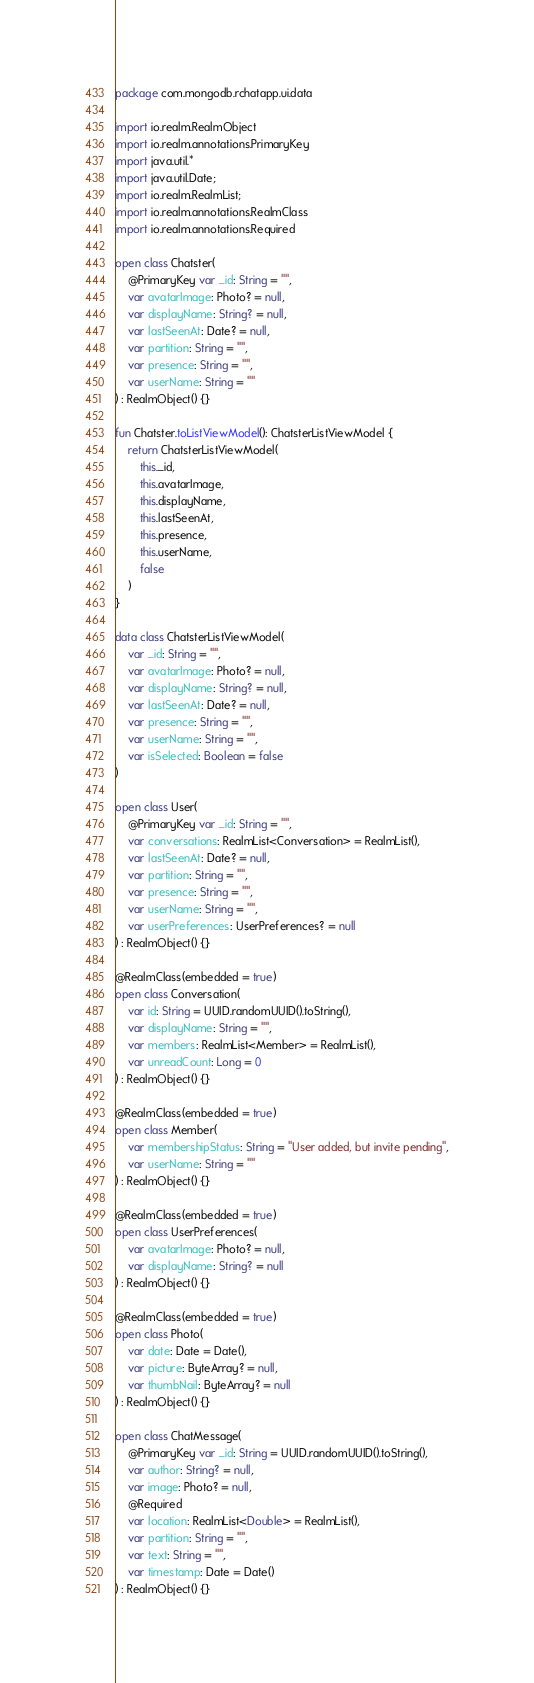Convert code to text. <code><loc_0><loc_0><loc_500><loc_500><_Kotlin_>package com.mongodb.rchatapp.ui.data

import io.realm.RealmObject
import io.realm.annotations.PrimaryKey
import java.util.*
import java.util.Date;
import io.realm.RealmList;
import io.realm.annotations.RealmClass
import io.realm.annotations.Required

open class Chatster(
    @PrimaryKey var _id: String = "",
    var avatarImage: Photo? = null,
    var displayName: String? = null,
    var lastSeenAt: Date? = null,
    var partition: String = "",
    var presence: String = "",
    var userName: String = ""
) : RealmObject() {}

fun Chatster.toListViewModel(): ChatsterListViewModel {
    return ChatsterListViewModel(
        this._id,
        this.avatarImage,
        this.displayName,
        this.lastSeenAt,
        this.presence,
        this.userName,
        false
    )
}

data class ChatsterListViewModel(
    var _id: String = "",
    var avatarImage: Photo? = null,
    var displayName: String? = null,
    var lastSeenAt: Date? = null,
    var presence: String = "",
    var userName: String = "",
    var isSelected: Boolean = false
)

open class User(
    @PrimaryKey var _id: String = "",
    var conversations: RealmList<Conversation> = RealmList(),
    var lastSeenAt: Date? = null,
    var partition: String = "",
    var presence: String = "",
    var userName: String = "",
    var userPreferences: UserPreferences? = null
) : RealmObject() {}

@RealmClass(embedded = true)
open class Conversation(
    var id: String = UUID.randomUUID().toString(),
    var displayName: String = "",
    var members: RealmList<Member> = RealmList(),
    var unreadCount: Long = 0
) : RealmObject() {}

@RealmClass(embedded = true)
open class Member(
    var membershipStatus: String = "User added, but invite pending",
    var userName: String = ""
) : RealmObject() {}

@RealmClass(embedded = true)
open class UserPreferences(
    var avatarImage: Photo? = null,
    var displayName: String? = null
) : RealmObject() {}

@RealmClass(embedded = true)
open class Photo(
    var date: Date = Date(),
    var picture: ByteArray? = null,
    var thumbNail: ByteArray? = null
) : RealmObject() {}

open class ChatMessage(
    @PrimaryKey var _id: String = UUID.randomUUID().toString(),
    var author: String? = null,
    var image: Photo? = null,
    @Required
    var location: RealmList<Double> = RealmList(),
    var partition: String = "",
    var text: String = "",
    var timestamp: Date = Date()
) : RealmObject() {}</code> 